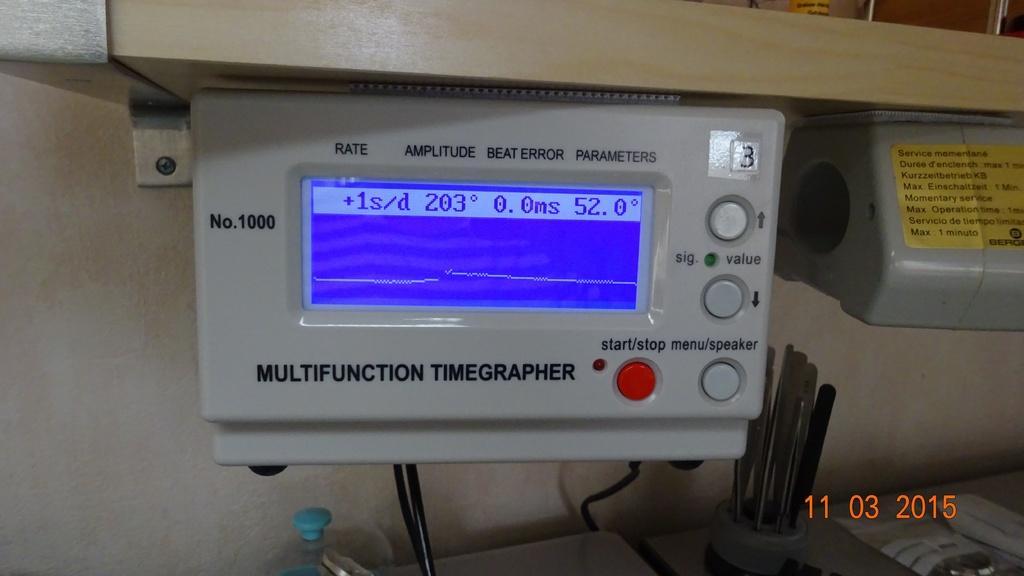Could you give a brief overview of what you see in this image? In this image there are electronic devices and objects. On that electronic device there is a sticker. Something is written on the electronic device and sticker. At the bottom right side of the image there is a watermark. 